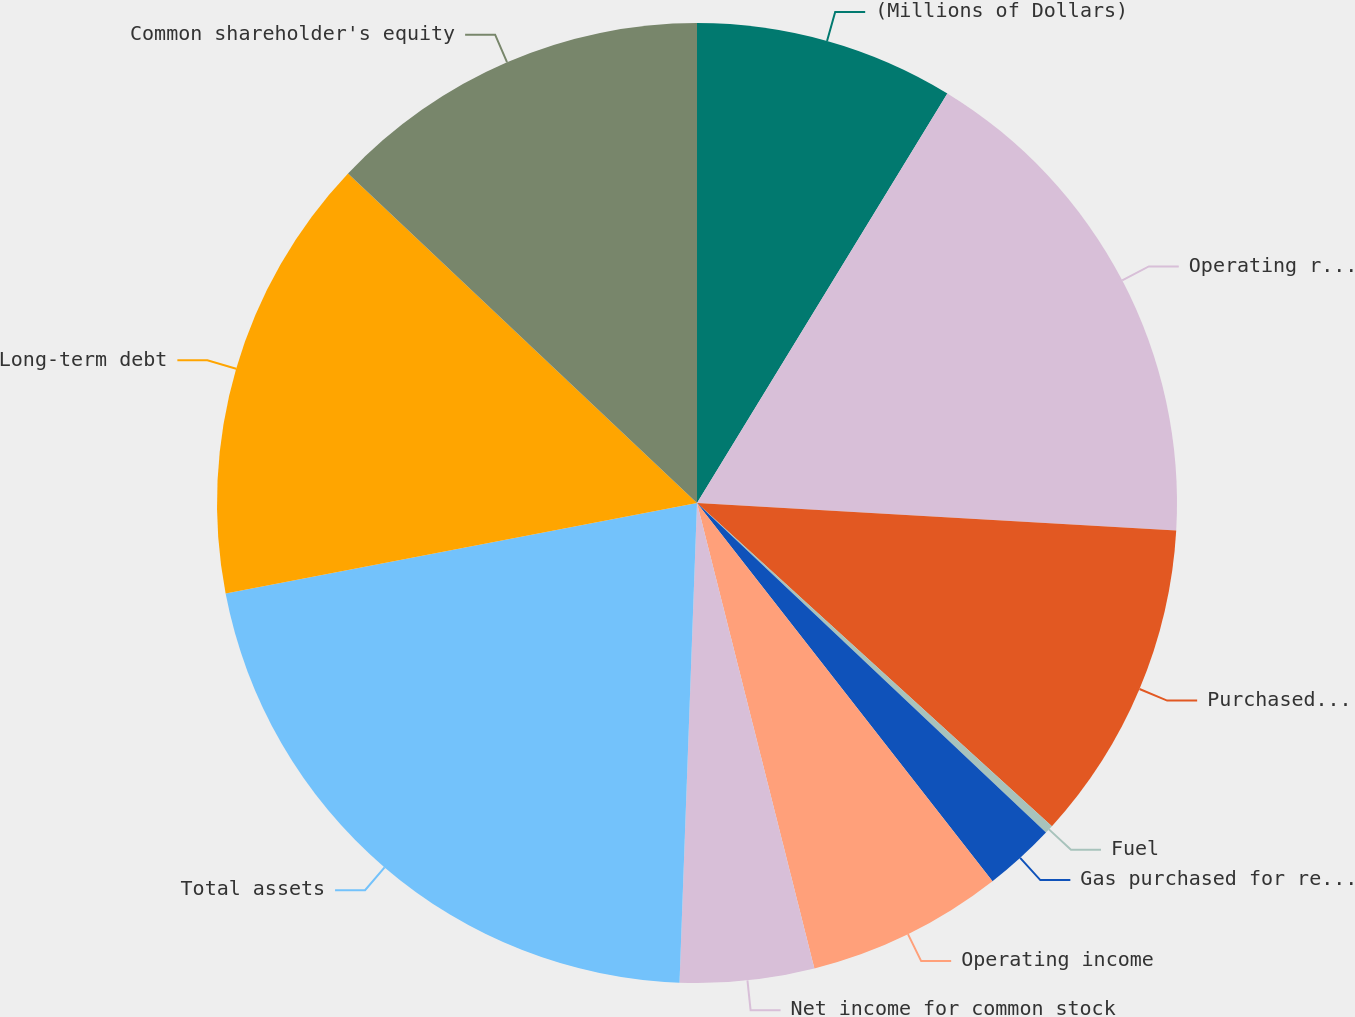Convert chart. <chart><loc_0><loc_0><loc_500><loc_500><pie_chart><fcel>(Millions of Dollars)<fcel>Operating revenues<fcel>Purchased power<fcel>Fuel<fcel>Gas purchased for resale<fcel>Operating income<fcel>Net income for common stock<fcel>Total assets<fcel>Long-term debt<fcel>Common shareholder's equity<nl><fcel>8.73%<fcel>17.17%<fcel>10.84%<fcel>0.29%<fcel>2.4%<fcel>6.62%<fcel>4.51%<fcel>21.39%<fcel>15.06%<fcel>12.95%<nl></chart> 